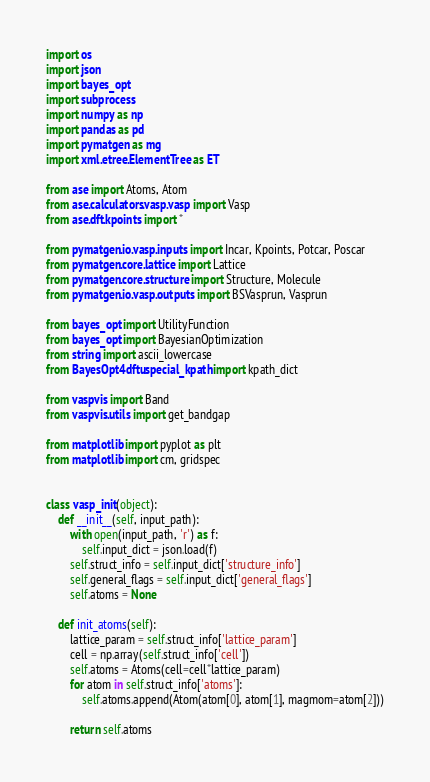Convert code to text. <code><loc_0><loc_0><loc_500><loc_500><_Python_>import os
import json
import bayes_opt
import subprocess
import numpy as np
import pandas as pd
import pymatgen as mg
import xml.etree.ElementTree as ET

from ase import Atoms, Atom
from ase.calculators.vasp.vasp import Vasp
from ase.dft.kpoints import *

from pymatgen.io.vasp.inputs import Incar, Kpoints, Potcar, Poscar
from pymatgen.core.lattice import Lattice
from pymatgen.core.structure import Structure, Molecule
from pymatgen.io.vasp.outputs import BSVasprun, Vasprun

from bayes_opt import UtilityFunction
from bayes_opt import BayesianOptimization
from string import ascii_lowercase
from BayesOpt4dftu.special_kpath import kpath_dict

from vaspvis import Band
from vaspvis.utils import get_bandgap

from matplotlib import pyplot as plt
from matplotlib import cm, gridspec


class vasp_init(object):
    def __init__(self, input_path):
        with open(input_path, 'r') as f:
            self.input_dict = json.load(f)
        self.struct_info = self.input_dict['structure_info']
        self.general_flags = self.input_dict['general_flags']
        self.atoms = None

    def init_atoms(self):
        lattice_param = self.struct_info['lattice_param']
        cell = np.array(self.struct_info['cell'])
        self.atoms = Atoms(cell=cell*lattice_param)
        for atom in self.struct_info['atoms']:
            self.atoms.append(Atom(atom[0], atom[1], magmom=atom[2]))

        return self.atoms
</code> 